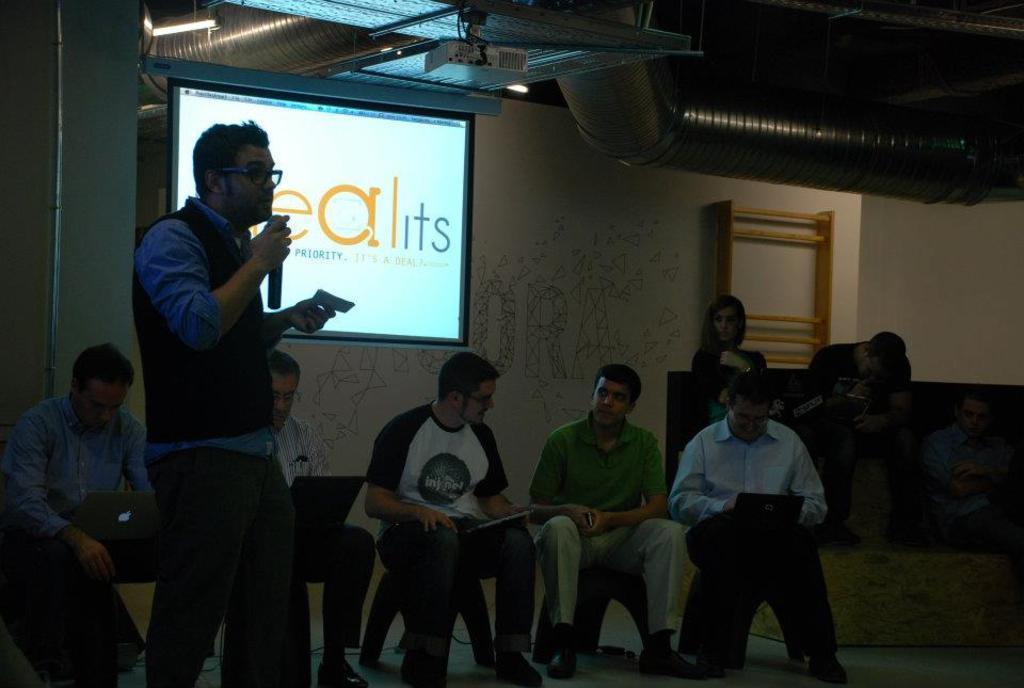How would you summarize this image in a sentence or two? On the left there is a man who is wearing spectacle, shirt, jacket and trouser. He is holding a mic and paper. Beside them we can see another man who is sitting on the bench and he is looking on the laptop. On the right there are three persons who are sitting on the couch. At the bottom there is a man who is wearing green t-shirt, trouser and shoe, beside him we can see another man who is wearing spectacle, t-shirt, jeans and shoe. He is holding a book. At the top we can see the projector. In the back we can see the projector screen near to the wall. In the top right we can see the ducts. 